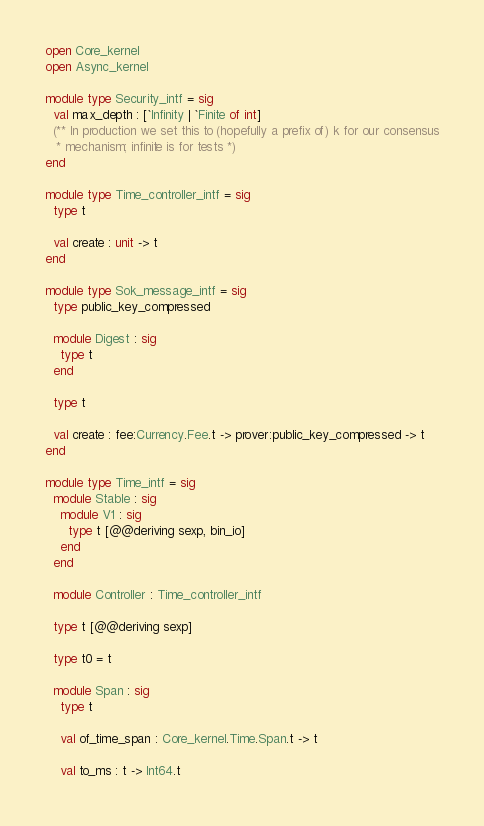<code> <loc_0><loc_0><loc_500><loc_500><_OCaml_>open Core_kernel
open Async_kernel

module type Security_intf = sig
  val max_depth : [`Infinity | `Finite of int]
  (** In production we set this to (hopefully a prefix of) k for our consensus
   * mechanism; infinite is for tests *)
end

module type Time_controller_intf = sig
  type t

  val create : unit -> t
end

module type Sok_message_intf = sig
  type public_key_compressed

  module Digest : sig
    type t
  end

  type t

  val create : fee:Currency.Fee.t -> prover:public_key_compressed -> t
end

module type Time_intf = sig
  module Stable : sig
    module V1 : sig
      type t [@@deriving sexp, bin_io]
    end
  end

  module Controller : Time_controller_intf

  type t [@@deriving sexp]

  type t0 = t

  module Span : sig
    type t

    val of_time_span : Core_kernel.Time.Span.t -> t

    val to_ms : t -> Int64.t
</code> 